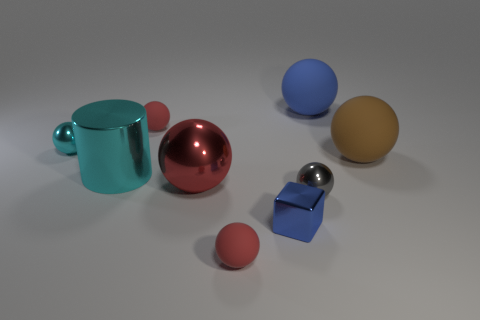Add 1 small cyan spheres. How many objects exist? 10 Subtract all tiny rubber balls. How many balls are left? 5 Subtract all gray cylinders. How many red balls are left? 3 Subtract all red spheres. How many spheres are left? 4 Subtract all balls. How many objects are left? 2 Add 6 tiny cyan things. How many tiny cyan things are left? 7 Add 7 red rubber things. How many red rubber things exist? 9 Subtract 0 yellow cylinders. How many objects are left? 9 Subtract 5 spheres. How many spheres are left? 2 Subtract all yellow blocks. Subtract all yellow cylinders. How many blocks are left? 1 